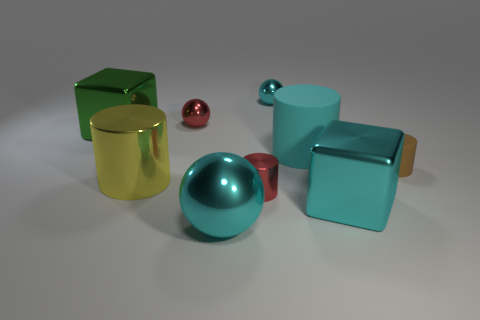Add 1 big blue rubber objects. How many objects exist? 10 Subtract all gray cylinders. Subtract all yellow blocks. How many cylinders are left? 4 Subtract all balls. How many objects are left? 6 Add 2 big yellow things. How many big yellow things exist? 3 Subtract 1 red cylinders. How many objects are left? 8 Subtract all tiny cyan spheres. Subtract all tiny cylinders. How many objects are left? 6 Add 7 large cyan spheres. How many large cyan spheres are left? 8 